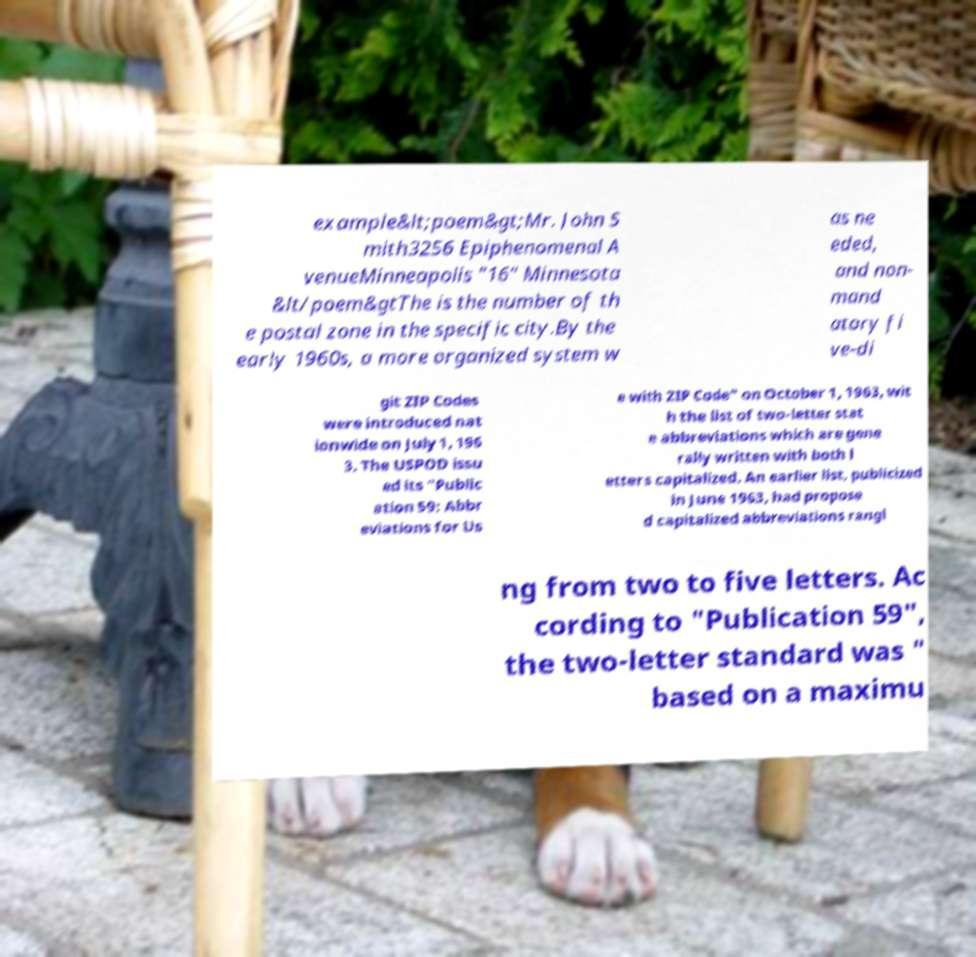Can you accurately transcribe the text from the provided image for me? example&lt;poem&gt;Mr. John S mith3256 Epiphenomenal A venueMinneapolis "16" Minnesota &lt/poem&gtThe is the number of th e postal zone in the specific city.By the early 1960s, a more organized system w as ne eded, and non- mand atory fi ve-di git ZIP Codes were introduced nat ionwide on July 1, 196 3. The USPOD issu ed its "Public ation 59: Abbr eviations for Us e with ZIP Code" on October 1, 1963, wit h the list of two-letter stat e abbreviations which are gene rally written with both l etters capitalized. An earlier list, publicized in June 1963, had propose d capitalized abbreviations rangi ng from two to five letters. Ac cording to "Publication 59", the two-letter standard was " based on a maximu 